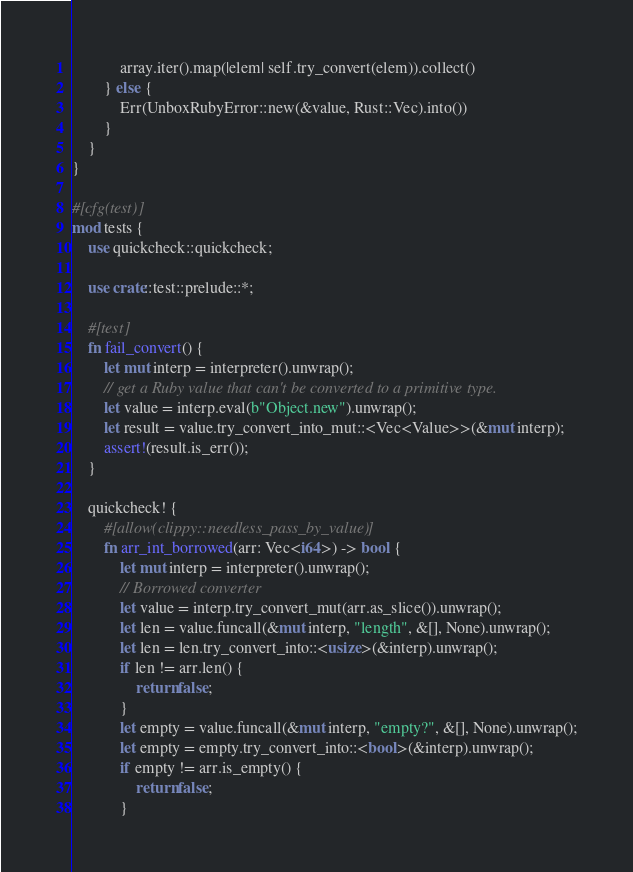<code> <loc_0><loc_0><loc_500><loc_500><_Rust_>            array.iter().map(|elem| self.try_convert(elem)).collect()
        } else {
            Err(UnboxRubyError::new(&value, Rust::Vec).into())
        }
    }
}

#[cfg(test)]
mod tests {
    use quickcheck::quickcheck;

    use crate::test::prelude::*;

    #[test]
    fn fail_convert() {
        let mut interp = interpreter().unwrap();
        // get a Ruby value that can't be converted to a primitive type.
        let value = interp.eval(b"Object.new").unwrap();
        let result = value.try_convert_into_mut::<Vec<Value>>(&mut interp);
        assert!(result.is_err());
    }

    quickcheck! {
        #[allow(clippy::needless_pass_by_value)]
        fn arr_int_borrowed(arr: Vec<i64>) -> bool {
            let mut interp = interpreter().unwrap();
            // Borrowed converter
            let value = interp.try_convert_mut(arr.as_slice()).unwrap();
            let len = value.funcall(&mut interp, "length", &[], None).unwrap();
            let len = len.try_convert_into::<usize>(&interp).unwrap();
            if len != arr.len() {
                return false;
            }
            let empty = value.funcall(&mut interp, "empty?", &[], None).unwrap();
            let empty = empty.try_convert_into::<bool>(&interp).unwrap();
            if empty != arr.is_empty() {
                return false;
            }</code> 